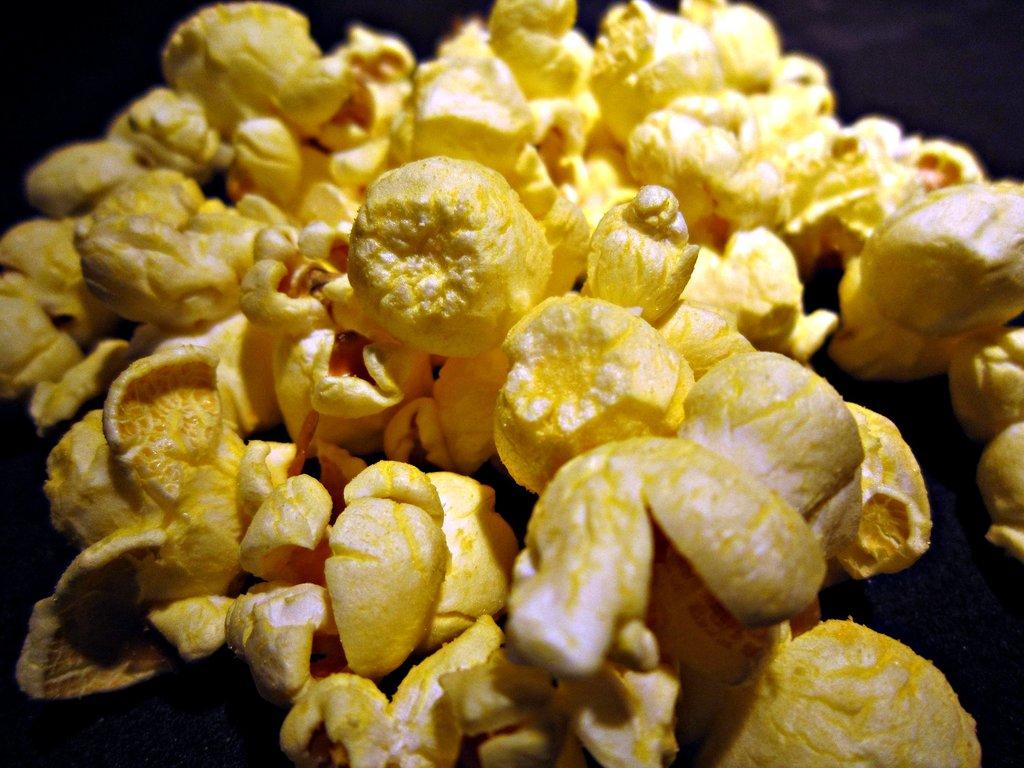What type of food is present in the image? There is popcorn in the picture. Can you describe the background of the image? The background of the picture appears to be dark. Is there a girl involved in a fight in the image? There is no girl or fight present in the image; it only features popcorn and a dark background. 